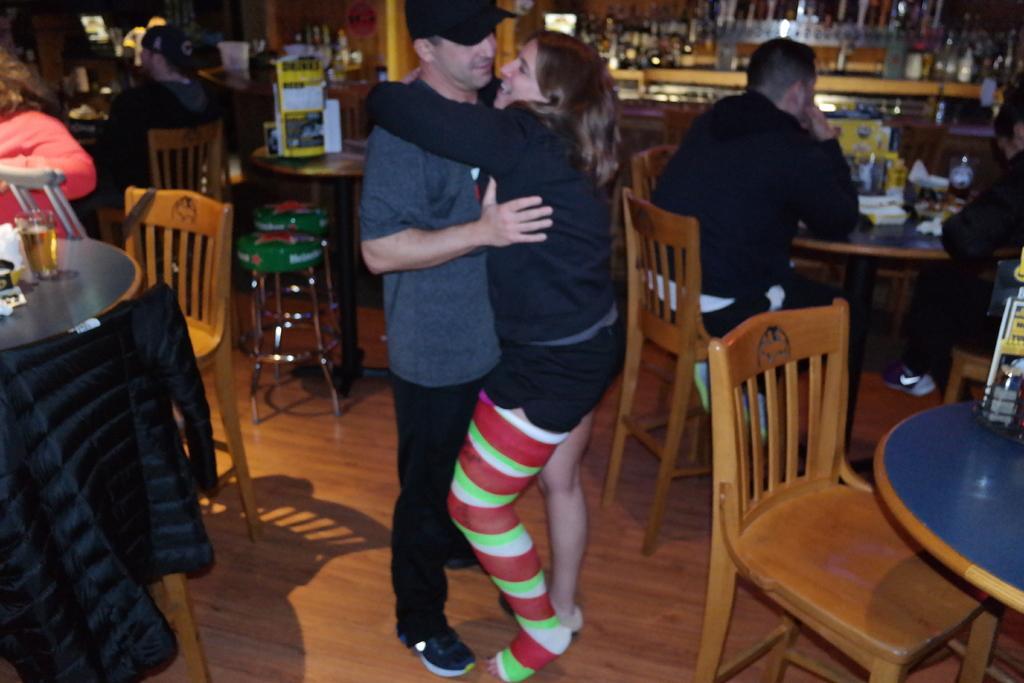In one or two sentences, can you explain what this image depicts? Here is the women and men standing. I can see some chairs. These are the two stools. This is a table with some things on it. I can see few people sitting on the chairs. This is the jerking on the chair. 